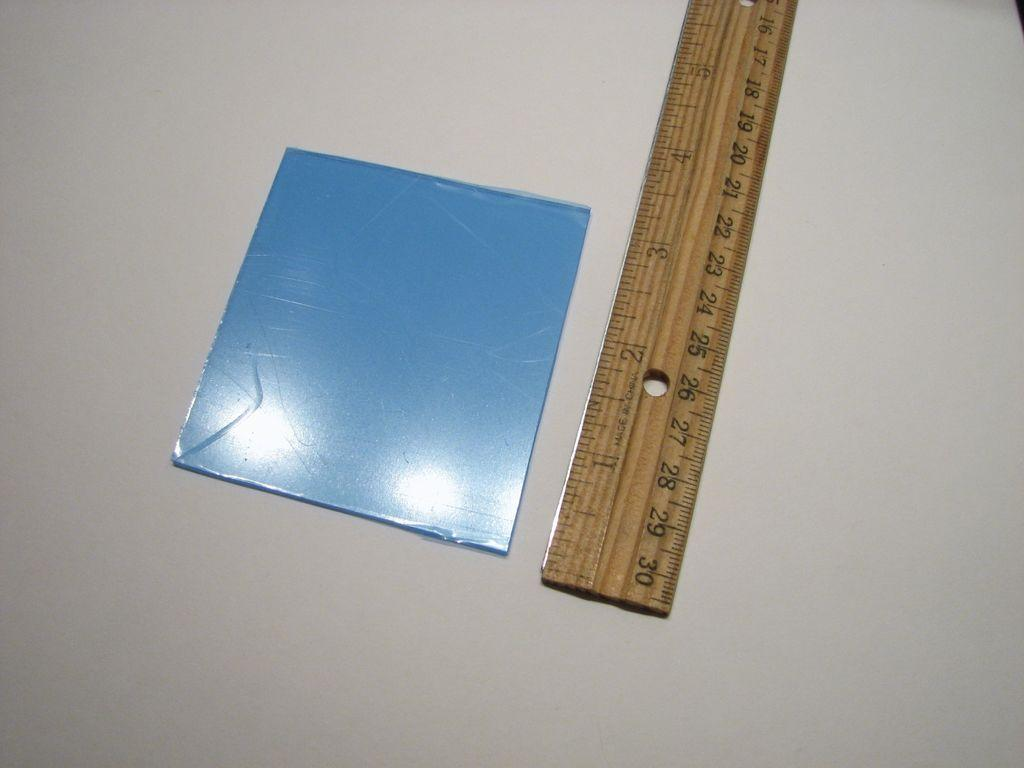Provide a one-sentence caption for the provided image. A ruler measures an object that is about 3 inches. 